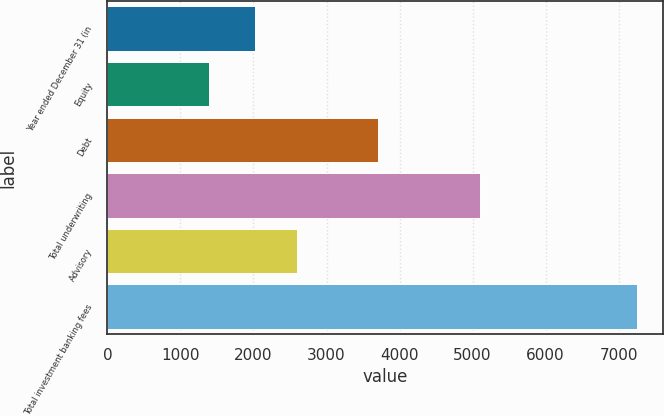Convert chart. <chart><loc_0><loc_0><loc_500><loc_500><bar_chart><fcel>Year ended December 31 (in<fcel>Equity<fcel>Debt<fcel>Total underwriting<fcel>Advisory<fcel>Total investment banking fees<nl><fcel>2017<fcel>1394<fcel>3710<fcel>5104<fcel>2602.4<fcel>7248<nl></chart> 